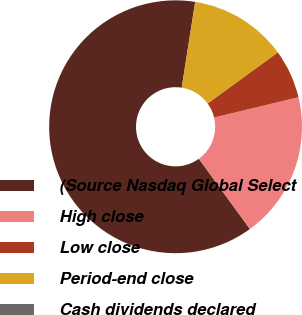Convert chart. <chart><loc_0><loc_0><loc_500><loc_500><pie_chart><fcel>(Source Nasdaq Global Select<fcel>High close<fcel>Low close<fcel>Period-end close<fcel>Cash dividends declared<nl><fcel>62.48%<fcel>18.75%<fcel>6.26%<fcel>12.5%<fcel>0.01%<nl></chart> 